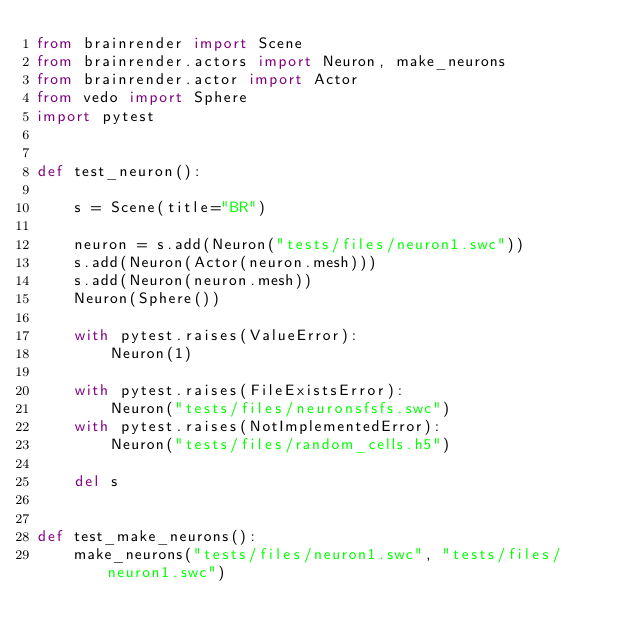<code> <loc_0><loc_0><loc_500><loc_500><_Python_>from brainrender import Scene
from brainrender.actors import Neuron, make_neurons
from brainrender.actor import Actor
from vedo import Sphere
import pytest


def test_neuron():

    s = Scene(title="BR")

    neuron = s.add(Neuron("tests/files/neuron1.swc"))
    s.add(Neuron(Actor(neuron.mesh)))
    s.add(Neuron(neuron.mesh))
    Neuron(Sphere())

    with pytest.raises(ValueError):
        Neuron(1)

    with pytest.raises(FileExistsError):
        Neuron("tests/files/neuronsfsfs.swc")
    with pytest.raises(NotImplementedError):
        Neuron("tests/files/random_cells.h5")

    del s


def test_make_neurons():
    make_neurons("tests/files/neuron1.swc", "tests/files/neuron1.swc")
</code> 